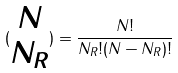Convert formula to latex. <formula><loc_0><loc_0><loc_500><loc_500>( \begin{matrix} N \\ N _ { R } \end{matrix} ) = \frac { N ! } { N _ { R } ! ( N - N _ { R } ) ! }</formula> 